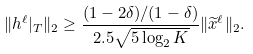<formula> <loc_0><loc_0><loc_500><loc_500>\| h ^ { \ell } | _ { T } \| _ { 2 } \geq \frac { ( 1 - 2 \delta ) / ( 1 - \delta ) } { 2 . 5 \sqrt { 5 \log _ { 2 } K } } \| \widetilde { x } ^ { \ell } \| _ { 2 } .</formula> 